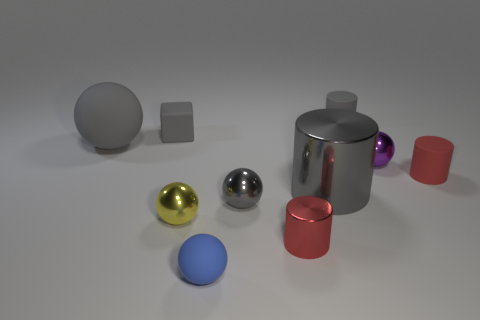Does the block have the same size as the metallic thing that is left of the small gray ball?
Keep it short and to the point. Yes. What is the size of the red cylinder that is left of the small red object that is behind the metal object that is on the left side of the blue rubber ball?
Offer a terse response. Small. There is a purple metallic ball right of the big cylinder; how big is it?
Your answer should be very brief. Small. There is a blue object that is made of the same material as the gray block; what shape is it?
Provide a succinct answer. Sphere. Is the tiny sphere that is in front of the tiny yellow metallic ball made of the same material as the small gray cube?
Give a very brief answer. Yes. How many other things are there of the same material as the large gray cylinder?
Your answer should be very brief. 4. How many things are either rubber things that are behind the tiny block or small gray shiny balls behind the blue matte thing?
Offer a very short reply. 2. Does the small shiny thing behind the gray shiny cylinder have the same shape as the large gray thing behind the tiny purple metallic sphere?
Provide a short and direct response. Yes. There is a yellow shiny thing that is the same size as the gray rubber cube; what is its shape?
Your response must be concise. Sphere. What number of metallic things are small purple objects or small gray things?
Your answer should be very brief. 2. 